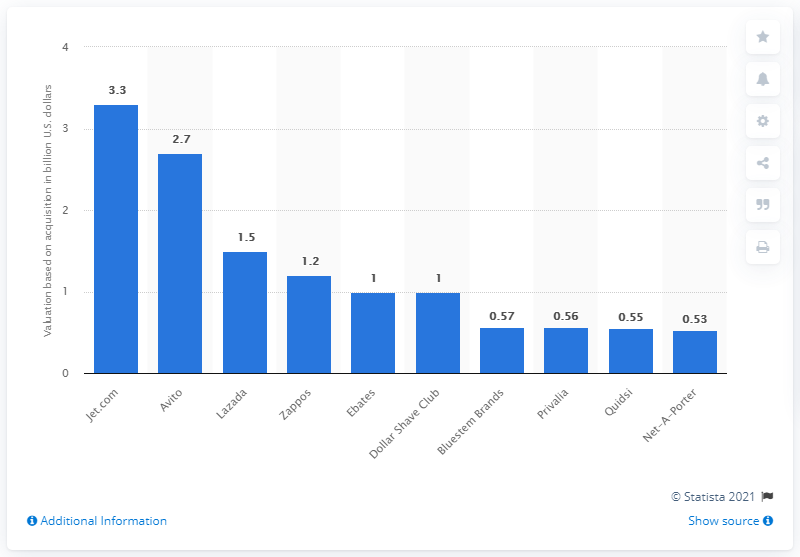Point out several critical features in this image. The most expensive e-commerce startup purchase was Jet.com. 